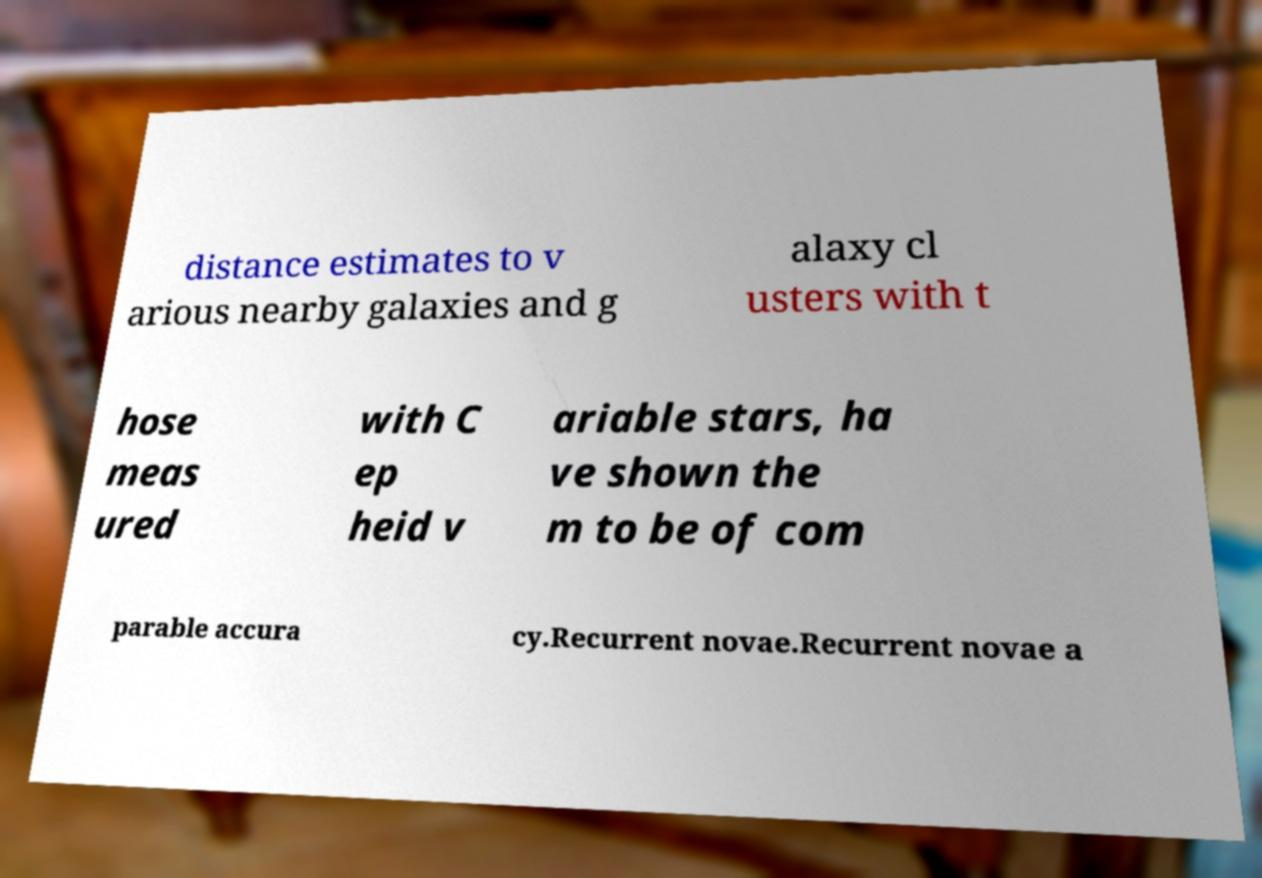Could you assist in decoding the text presented in this image and type it out clearly? distance estimates to v arious nearby galaxies and g alaxy cl usters with t hose meas ured with C ep heid v ariable stars, ha ve shown the m to be of com parable accura cy.Recurrent novae.Recurrent novae a 